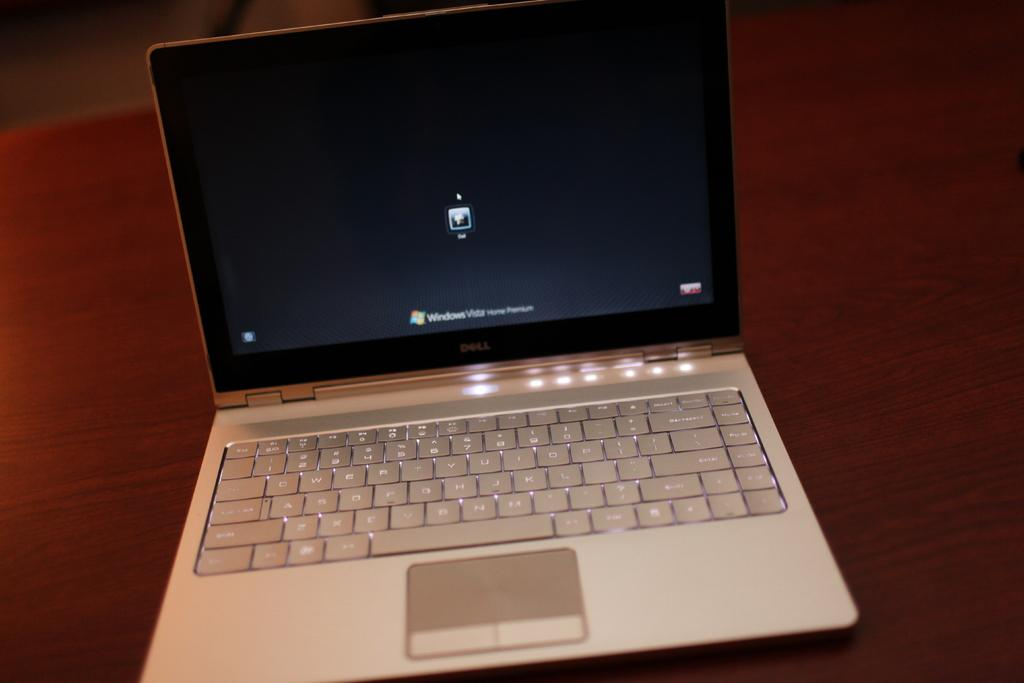<image>
Present a compact description of the photo's key features. a computer with the word windows on it 